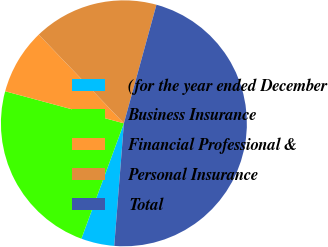Convert chart. <chart><loc_0><loc_0><loc_500><loc_500><pie_chart><fcel>(for the year ended December<fcel>Business Insurance<fcel>Financial Professional &<fcel>Personal Insurance<fcel>Total<nl><fcel>4.37%<fcel>23.58%<fcel>8.63%<fcel>16.44%<fcel>46.99%<nl></chart> 